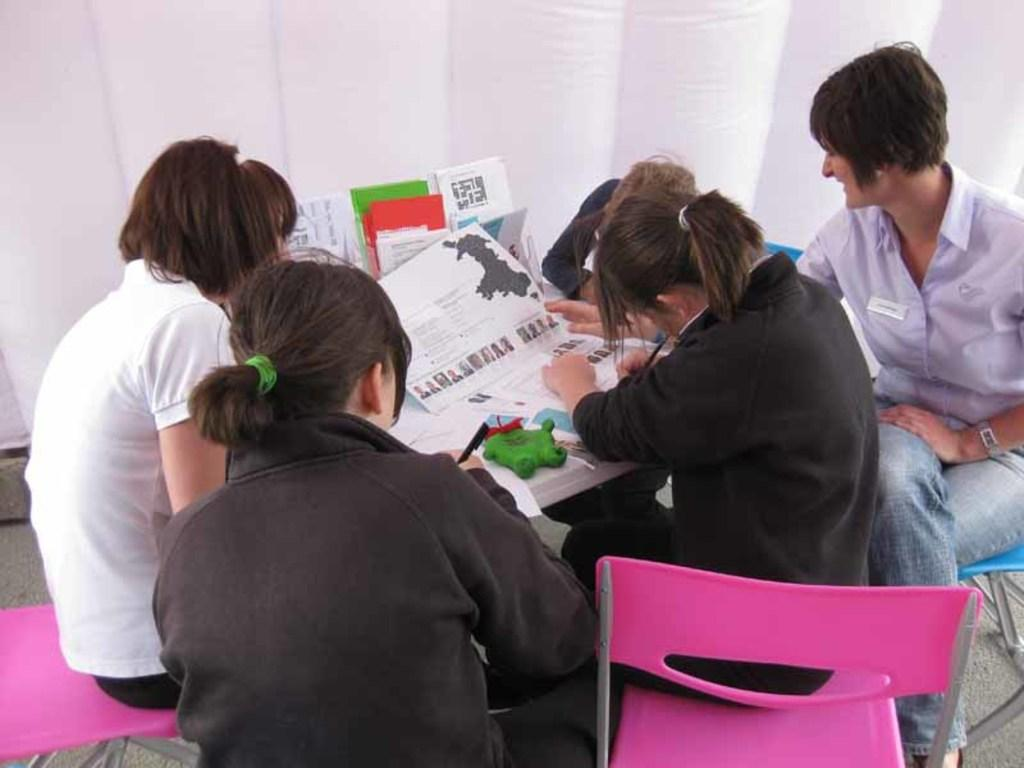What are the people in the image doing? The people in the image are sitting on chairs. What is present in the image besides the people? There is a table in the image. What is on the table? There are papers on the table. What is the tendency of the harmony in the image? There is no mention of harmony in the image, so it is not possible to determine its tendency. 